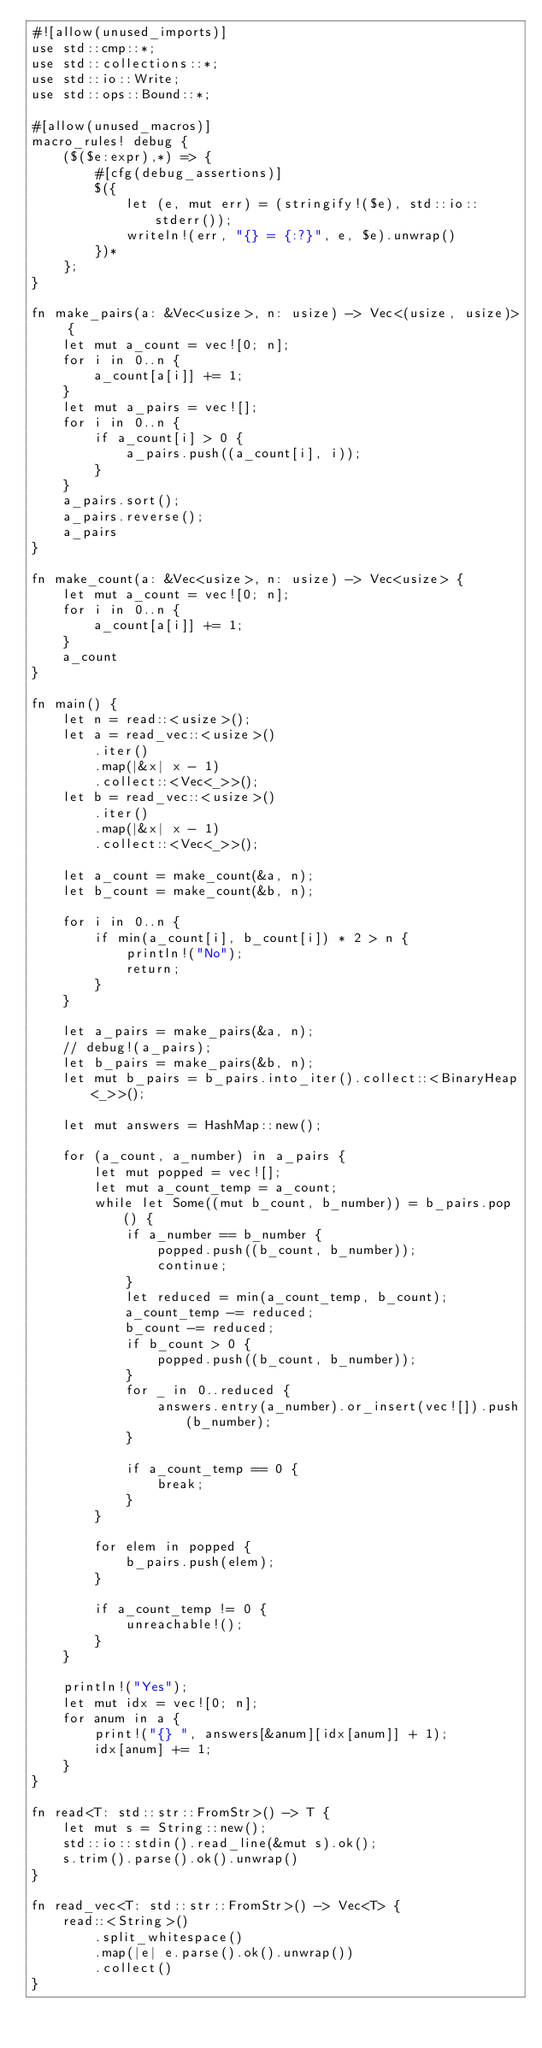<code> <loc_0><loc_0><loc_500><loc_500><_Rust_>#![allow(unused_imports)]
use std::cmp::*;
use std::collections::*;
use std::io::Write;
use std::ops::Bound::*;

#[allow(unused_macros)]
macro_rules! debug {
    ($($e:expr),*) => {
        #[cfg(debug_assertions)]
        $({
            let (e, mut err) = (stringify!($e), std::io::stderr());
            writeln!(err, "{} = {:?}", e, $e).unwrap()
        })*
    };
}

fn make_pairs(a: &Vec<usize>, n: usize) -> Vec<(usize, usize)> {
    let mut a_count = vec![0; n];
    for i in 0..n {
        a_count[a[i]] += 1;
    }
    let mut a_pairs = vec![];
    for i in 0..n {
        if a_count[i] > 0 {
            a_pairs.push((a_count[i], i));
        }
    }
    a_pairs.sort();
    a_pairs.reverse();
    a_pairs
}

fn make_count(a: &Vec<usize>, n: usize) -> Vec<usize> {
    let mut a_count = vec![0; n];
    for i in 0..n {
        a_count[a[i]] += 1;
    }
    a_count
}

fn main() {
    let n = read::<usize>();
    let a = read_vec::<usize>()
        .iter()
        .map(|&x| x - 1)
        .collect::<Vec<_>>();
    let b = read_vec::<usize>()
        .iter()
        .map(|&x| x - 1)
        .collect::<Vec<_>>();

    let a_count = make_count(&a, n);
    let b_count = make_count(&b, n);

    for i in 0..n {
        if min(a_count[i], b_count[i]) * 2 > n {
            println!("No");
            return;
        }
    }

    let a_pairs = make_pairs(&a, n);
    // debug!(a_pairs);
    let b_pairs = make_pairs(&b, n);
    let mut b_pairs = b_pairs.into_iter().collect::<BinaryHeap<_>>();

    let mut answers = HashMap::new();

    for (a_count, a_number) in a_pairs {
        let mut popped = vec![];
        let mut a_count_temp = a_count;
        while let Some((mut b_count, b_number)) = b_pairs.pop() {
            if a_number == b_number {
                popped.push((b_count, b_number));
                continue;
            }
            let reduced = min(a_count_temp, b_count);
            a_count_temp -= reduced;
            b_count -= reduced;
            if b_count > 0 {
                popped.push((b_count, b_number));
            }
            for _ in 0..reduced {
                answers.entry(a_number).or_insert(vec![]).push(b_number);
            }

            if a_count_temp == 0 {
                break;
            }
        }

        for elem in popped {
            b_pairs.push(elem);
        }

        if a_count_temp != 0 {
            unreachable!();
        }
    }

    println!("Yes");
    let mut idx = vec![0; n];
    for anum in a {
        print!("{} ", answers[&anum][idx[anum]] + 1);
        idx[anum] += 1;
    }
}

fn read<T: std::str::FromStr>() -> T {
    let mut s = String::new();
    std::io::stdin().read_line(&mut s).ok();
    s.trim().parse().ok().unwrap()
}

fn read_vec<T: std::str::FromStr>() -> Vec<T> {
    read::<String>()
        .split_whitespace()
        .map(|e| e.parse().ok().unwrap())
        .collect()
}
</code> 